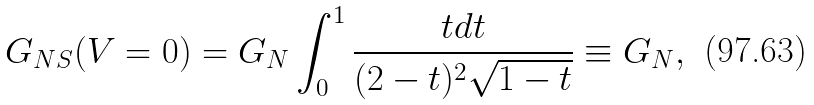Convert formula to latex. <formula><loc_0><loc_0><loc_500><loc_500>G _ { N S } ( V = 0 ) = G _ { N } \int _ { 0 } ^ { 1 } \frac { t d t } { ( 2 - t ) ^ { 2 } \sqrt { 1 - t } } \equiv G _ { N } ,</formula> 